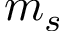<formula> <loc_0><loc_0><loc_500><loc_500>m _ { s }</formula> 